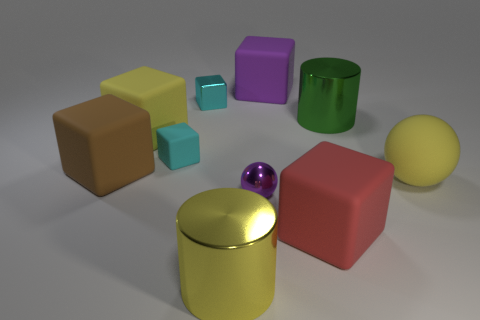Is the number of cyan metallic things in front of the large green metallic object less than the number of big red matte cubes that are behind the small cyan matte block?
Offer a very short reply. No. Does the purple metallic thing have the same shape as the green thing?
Ensure brevity in your answer.  No. How many metal cylinders are the same size as the purple cube?
Offer a terse response. 2. Are there fewer red cubes behind the rubber sphere than blue metal balls?
Ensure brevity in your answer.  No. How big is the metal cylinder that is behind the big object in front of the large red thing?
Your answer should be compact. Large. How many objects are small brown metal spheres or large red objects?
Offer a very short reply. 1. Are there any other small rubber cubes of the same color as the tiny matte cube?
Ensure brevity in your answer.  No. Is the number of big red metal things less than the number of small cyan metal cubes?
Ensure brevity in your answer.  Yes. How many objects are either yellow objects or cyan rubber cubes that are behind the yellow matte ball?
Your response must be concise. 4. Is there a green thing made of the same material as the big green cylinder?
Keep it short and to the point. No. 